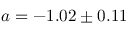<formula> <loc_0><loc_0><loc_500><loc_500>a = - 1 . 0 2 \pm 0 . 1 1</formula> 